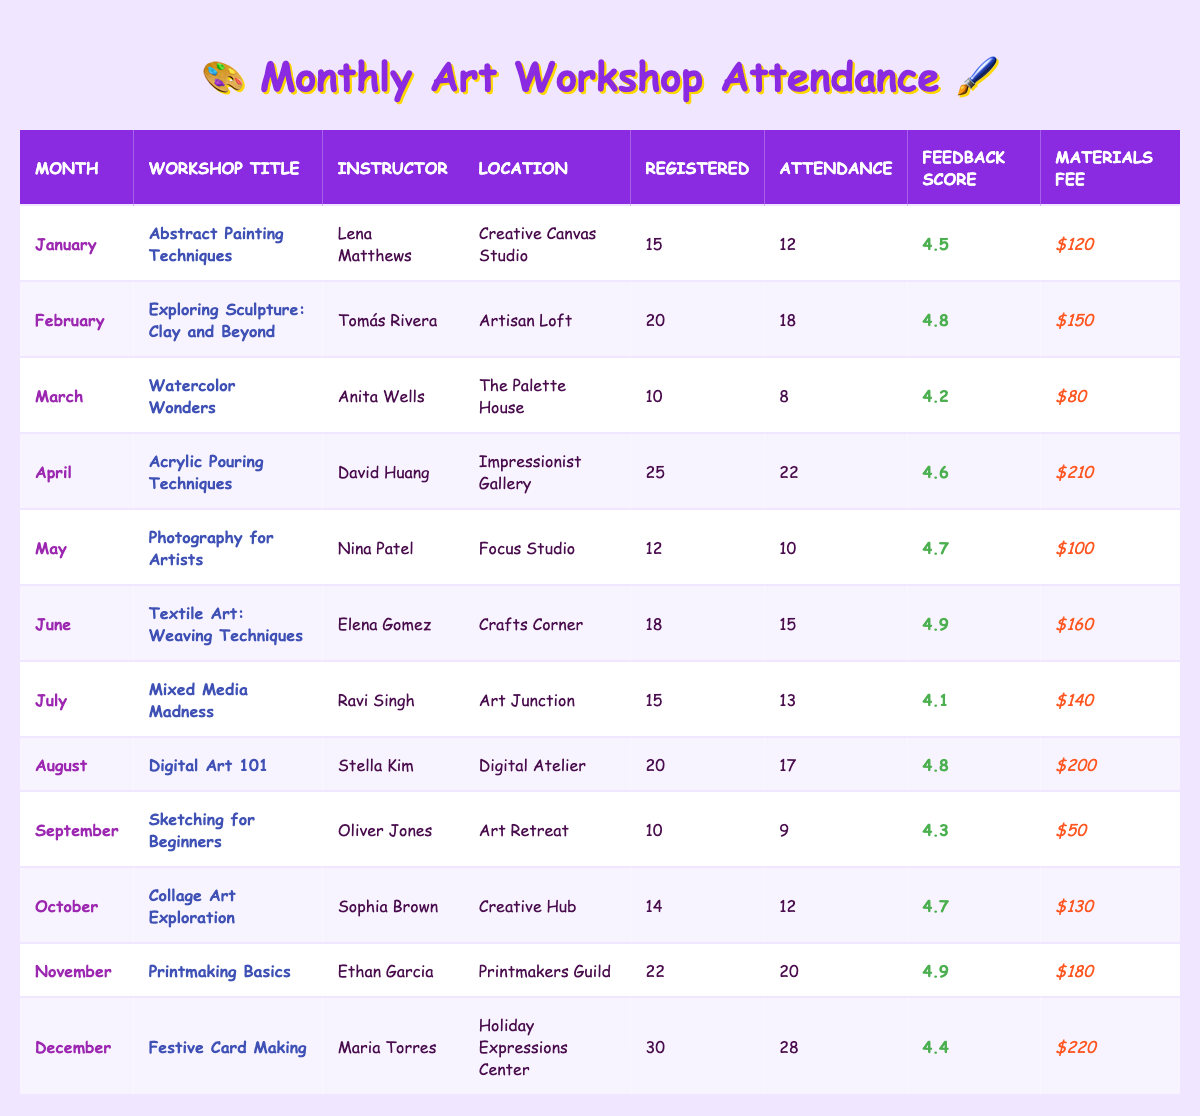What is the attendance for the workshop "Digital Art 101"? To find this, I look for the row with "Digital Art 101" in the Workshop Title column, which shows an attendance of 17.
Answer: 17 Which month had the highest feedback score? I review the Feedback Score column and see the highest score is 4.9, which corresponds to the months of June and November.
Answer: June and November How many registered participants were there for the "Acrylic Pouring Techniques" workshop? I locate the "Acrylic Pouring Techniques" workshop in the table, and the Registered Participants value is 25.
Answer: 25 What is the average attendance across all workshops for the year? I calculate the total attendance by adding all values (12 + 18 + 8 + 22 + 10 + 15 + 13 + 17 + 9 + 12 + 20 + 28 =  8). There are 12 workshops, so 164/12 = 13.67 (rounded to 14).
Answer: 14 Did the "Watercolor Wonders" workshop have more registered participants than attendees? The registered participants for "Watercolor Wonders" is 10, and the attendance is 8, which is fewer than registered.
Answer: Yes What is the total materials fee collected across all workshops? I sum all the materials fee values ($120 + $150 + $80 + $210 + $100 + $160 + $140 + $200 + $50 + $130 + $180 + $220 = $1,620).
Answer: $1,620 How many workshops had attendance rates above 80% this year? I check each workshop's attendance against registered participants. The workshops with attendance rates above 80% are January (80%), February (90%), April (88%), June (83%), August (85%), November (90%), December (93%), which totals 7 workshops.
Answer: 7 What was the feedback score for the workshop with the least attendance? The workshop with the least attendance is "Watercolor Wonders" with an attendance of 8 and a feedback score of 4.2.
Answer: 4.2 Which workshop collected the most materials fee, and how much was it? I compare the materials fee for each workshop, finding that "Festive Card Making" collected the most at $220.
Answer: $220 Was there a workshop in April, and what was its attendance? Yes, the workshop in April was "Acrylic Pouring Techniques," which had an attendance of 22.
Answer: 22 